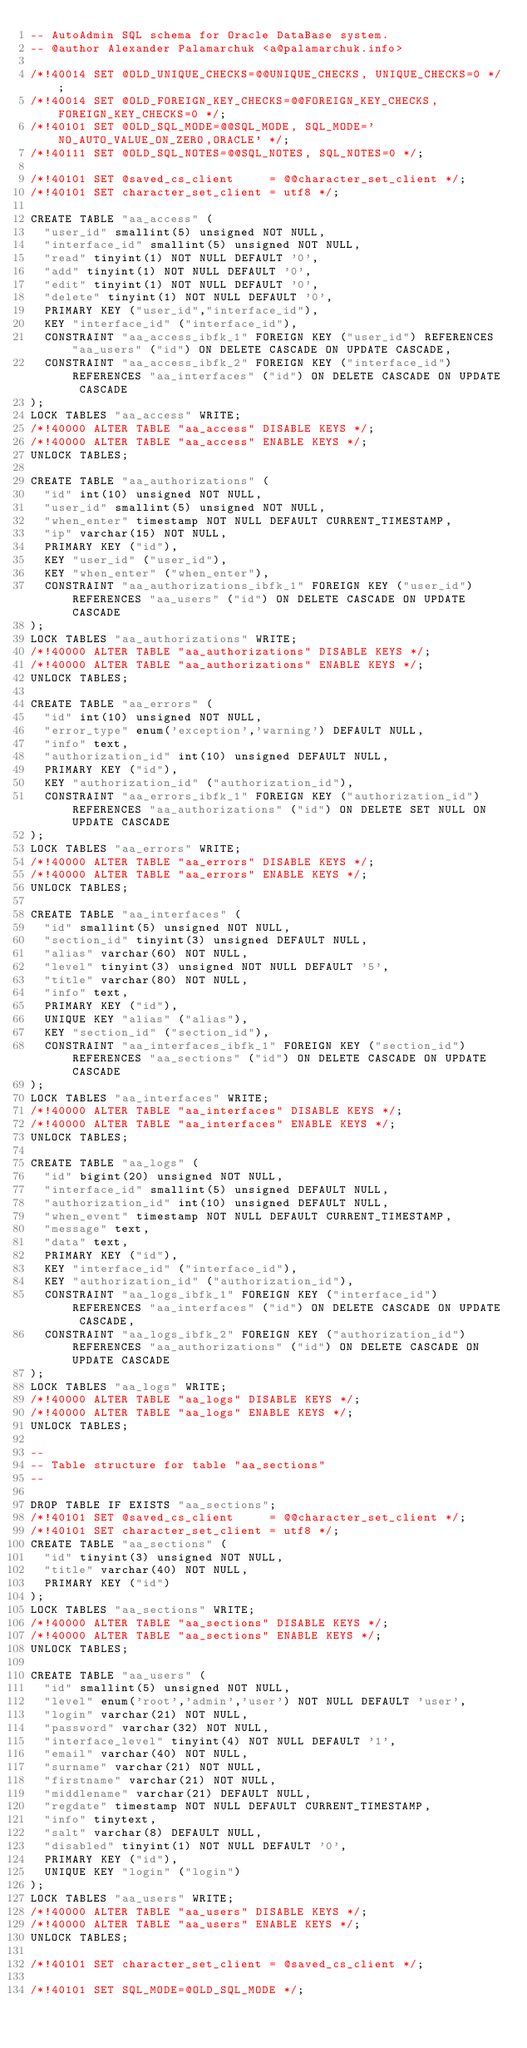<code> <loc_0><loc_0><loc_500><loc_500><_SQL_>-- AutoAdmin SQL schema for Oracle DataBase system.
-- @author Alexander Palamarchuk <a@palamarchuk.info>

/*!40014 SET @OLD_UNIQUE_CHECKS=@@UNIQUE_CHECKS, UNIQUE_CHECKS=0 */;
/*!40014 SET @OLD_FOREIGN_KEY_CHECKS=@@FOREIGN_KEY_CHECKS, FOREIGN_KEY_CHECKS=0 */;
/*!40101 SET @OLD_SQL_MODE=@@SQL_MODE, SQL_MODE='NO_AUTO_VALUE_ON_ZERO,ORACLE' */;
/*!40111 SET @OLD_SQL_NOTES=@@SQL_NOTES, SQL_NOTES=0 */;

/*!40101 SET @saved_cs_client     = @@character_set_client */;
/*!40101 SET character_set_client = utf8 */;

CREATE TABLE "aa_access" (
  "user_id" smallint(5) unsigned NOT NULL,
  "interface_id" smallint(5) unsigned NOT NULL,
  "read" tinyint(1) NOT NULL DEFAULT '0',
  "add" tinyint(1) NOT NULL DEFAULT '0',
  "edit" tinyint(1) NOT NULL DEFAULT '0',
  "delete" tinyint(1) NOT NULL DEFAULT '0',
  PRIMARY KEY ("user_id","interface_id"),
  KEY "interface_id" ("interface_id"),
  CONSTRAINT "aa_access_ibfk_1" FOREIGN KEY ("user_id") REFERENCES "aa_users" ("id") ON DELETE CASCADE ON UPDATE CASCADE,
  CONSTRAINT "aa_access_ibfk_2" FOREIGN KEY ("interface_id") REFERENCES "aa_interfaces" ("id") ON DELETE CASCADE ON UPDATE CASCADE
);
LOCK TABLES "aa_access" WRITE;
/*!40000 ALTER TABLE "aa_access" DISABLE KEYS */;
/*!40000 ALTER TABLE "aa_access" ENABLE KEYS */;
UNLOCK TABLES;

CREATE TABLE "aa_authorizations" (
  "id" int(10) unsigned NOT NULL,
  "user_id" smallint(5) unsigned NOT NULL,
  "when_enter" timestamp NOT NULL DEFAULT CURRENT_TIMESTAMP,
  "ip" varchar(15) NOT NULL,
  PRIMARY KEY ("id"),
  KEY "user_id" ("user_id"),
  KEY "when_enter" ("when_enter"),
  CONSTRAINT "aa_authorizations_ibfk_1" FOREIGN KEY ("user_id") REFERENCES "aa_users" ("id") ON DELETE CASCADE ON UPDATE CASCADE
);
LOCK TABLES "aa_authorizations" WRITE;
/*!40000 ALTER TABLE "aa_authorizations" DISABLE KEYS */;
/*!40000 ALTER TABLE "aa_authorizations" ENABLE KEYS */;
UNLOCK TABLES;

CREATE TABLE "aa_errors" (
  "id" int(10) unsigned NOT NULL,
  "error_type" enum('exception','warning') DEFAULT NULL,
  "info" text,
  "authorization_id" int(10) unsigned DEFAULT NULL,
  PRIMARY KEY ("id"),
  KEY "authorization_id" ("authorization_id"),
  CONSTRAINT "aa_errors_ibfk_1" FOREIGN KEY ("authorization_id") REFERENCES "aa_authorizations" ("id") ON DELETE SET NULL ON UPDATE CASCADE
);
LOCK TABLES "aa_errors" WRITE;
/*!40000 ALTER TABLE "aa_errors" DISABLE KEYS */;
/*!40000 ALTER TABLE "aa_errors" ENABLE KEYS */;
UNLOCK TABLES;

CREATE TABLE "aa_interfaces" (
  "id" smallint(5) unsigned NOT NULL,
  "section_id" tinyint(3) unsigned DEFAULT NULL,
  "alias" varchar(60) NOT NULL,
  "level" tinyint(3) unsigned NOT NULL DEFAULT '5',
  "title" varchar(80) NOT NULL,
  "info" text,
  PRIMARY KEY ("id"),
  UNIQUE KEY "alias" ("alias"),
  KEY "section_id" ("section_id"),
  CONSTRAINT "aa_interfaces_ibfk_1" FOREIGN KEY ("section_id") REFERENCES "aa_sections" ("id") ON DELETE CASCADE ON UPDATE CASCADE
);
LOCK TABLES "aa_interfaces" WRITE;
/*!40000 ALTER TABLE "aa_interfaces" DISABLE KEYS */;
/*!40000 ALTER TABLE "aa_interfaces" ENABLE KEYS */;
UNLOCK TABLES;

CREATE TABLE "aa_logs" (
  "id" bigint(20) unsigned NOT NULL,
  "interface_id" smallint(5) unsigned DEFAULT NULL,
  "authorization_id" int(10) unsigned DEFAULT NULL,
  "when_event" timestamp NOT NULL DEFAULT CURRENT_TIMESTAMP,
  "message" text,
  "data" text,
  PRIMARY KEY ("id"),
  KEY "interface_id" ("interface_id"),
  KEY "authorization_id" ("authorization_id"),
  CONSTRAINT "aa_logs_ibfk_1" FOREIGN KEY ("interface_id") REFERENCES "aa_interfaces" ("id") ON DELETE CASCADE ON UPDATE CASCADE,
  CONSTRAINT "aa_logs_ibfk_2" FOREIGN KEY ("authorization_id") REFERENCES "aa_authorizations" ("id") ON DELETE CASCADE ON UPDATE CASCADE
);
LOCK TABLES "aa_logs" WRITE;
/*!40000 ALTER TABLE "aa_logs" DISABLE KEYS */;
/*!40000 ALTER TABLE "aa_logs" ENABLE KEYS */;
UNLOCK TABLES;

--
-- Table structure for table "aa_sections"
--

DROP TABLE IF EXISTS "aa_sections";
/*!40101 SET @saved_cs_client     = @@character_set_client */;
/*!40101 SET character_set_client = utf8 */;
CREATE TABLE "aa_sections" (
  "id" tinyint(3) unsigned NOT NULL,
  "title" varchar(40) NOT NULL,
  PRIMARY KEY ("id")
);
LOCK TABLES "aa_sections" WRITE;
/*!40000 ALTER TABLE "aa_sections" DISABLE KEYS */;
/*!40000 ALTER TABLE "aa_sections" ENABLE KEYS */;
UNLOCK TABLES;

CREATE TABLE "aa_users" (
  "id" smallint(5) unsigned NOT NULL,
  "level" enum('root','admin','user') NOT NULL DEFAULT 'user',
  "login" varchar(21) NOT NULL,
  "password" varchar(32) NOT NULL,
  "interface_level" tinyint(4) NOT NULL DEFAULT '1',
  "email" varchar(40) NOT NULL,
  "surname" varchar(21) NOT NULL,
  "firstname" varchar(21) NOT NULL,
  "middlename" varchar(21) DEFAULT NULL,
  "regdate" timestamp NOT NULL DEFAULT CURRENT_TIMESTAMP,
  "info" tinytext,
  "salt" varchar(8) DEFAULT NULL,
  "disabled" tinyint(1) NOT NULL DEFAULT '0',
  PRIMARY KEY ("id"),
  UNIQUE KEY "login" ("login")
);
LOCK TABLES "aa_users" WRITE;
/*!40000 ALTER TABLE "aa_users" DISABLE KEYS */;
/*!40000 ALTER TABLE "aa_users" ENABLE KEYS */;
UNLOCK TABLES;

/*!40101 SET character_set_client = @saved_cs_client */;

/*!40101 SET SQL_MODE=@OLD_SQL_MODE */;</code> 